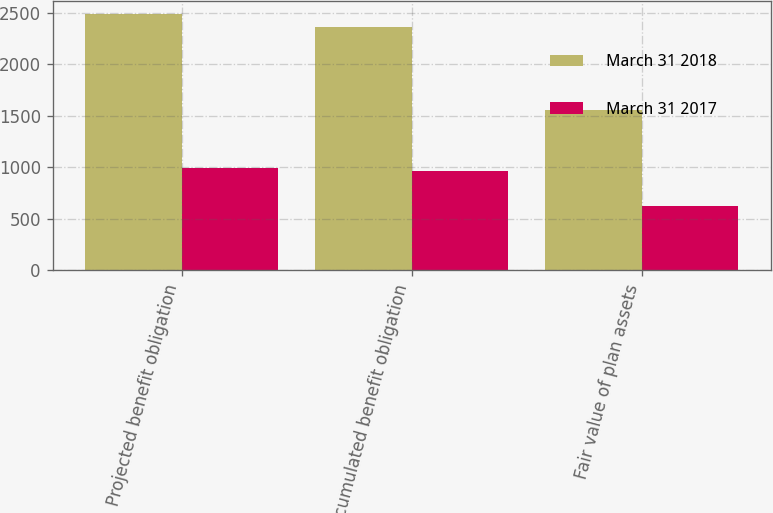Convert chart. <chart><loc_0><loc_0><loc_500><loc_500><stacked_bar_chart><ecel><fcel>Projected benefit obligation<fcel>Accumulated benefit obligation<fcel>Fair value of plan assets<nl><fcel>March 31 2018<fcel>2488<fcel>2363<fcel>1552<nl><fcel>March 31 2017<fcel>996<fcel>963<fcel>624<nl></chart> 